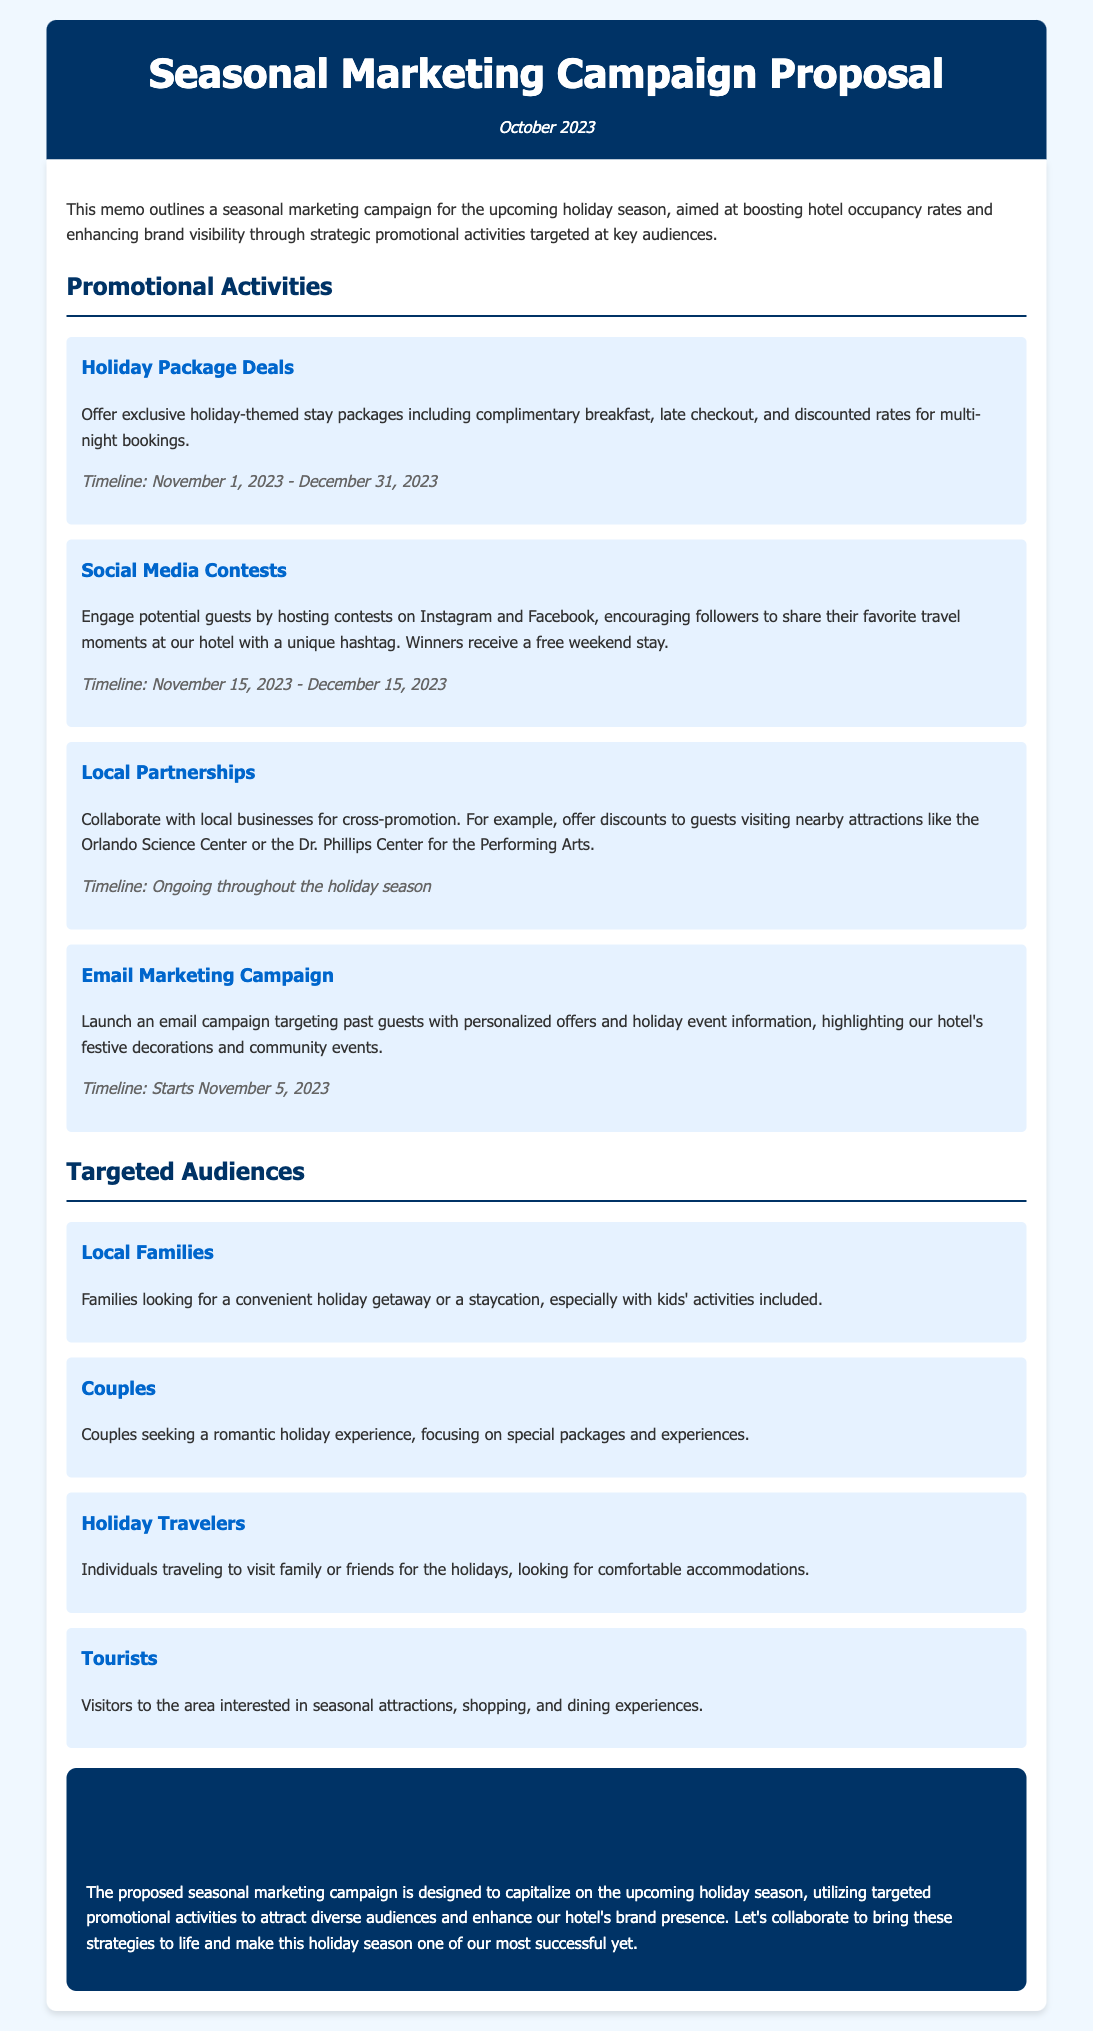What is the main purpose of the memo? The memo outlines a seasonal marketing campaign aimed at boosting hotel occupancy rates and enhancing brand visibility.
Answer: Boosting hotel occupancy rates What is the timeline for the Holiday Package Deals? The timeline specifies when the Holiday Package Deals will be available.
Answer: November 1, 2023 - December 31, 2023 What social media platforms will the contests take place on? The document names the platforms for hosting social media contests.
Answer: Instagram and Facebook Who are the targeted audiences for the campaign? The document lists specific groups intended to be reached by the marketing campaign.
Answer: Local Families, Couples, Holiday Travelers, Tourists What type of partnerships does the campaign propose? This question looks for the strategy involving collaboration with other entities outlined in the document.
Answer: Local Partnerships When does the email marketing campaign start? The document provides a specific date when the email campaign will commence.
Answer: November 5, 2023 What will winners of the social media contests receive? This question seeks to identify the reward for participants in the contests.
Answer: A free weekend stay 